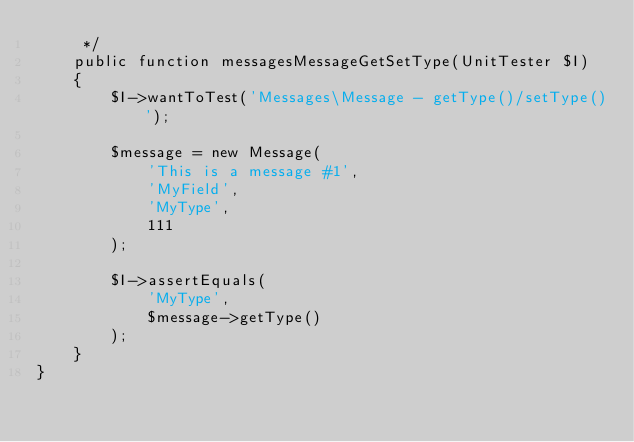Convert code to text. <code><loc_0><loc_0><loc_500><loc_500><_PHP_>     */
    public function messagesMessageGetSetType(UnitTester $I)
    {
        $I->wantToTest('Messages\Message - getType()/setType()');

        $message = new Message(
            'This is a message #1',
            'MyField',
            'MyType',
            111
        );

        $I->assertEquals(
            'MyType',
            $message->getType()
        );
    }
}
</code> 